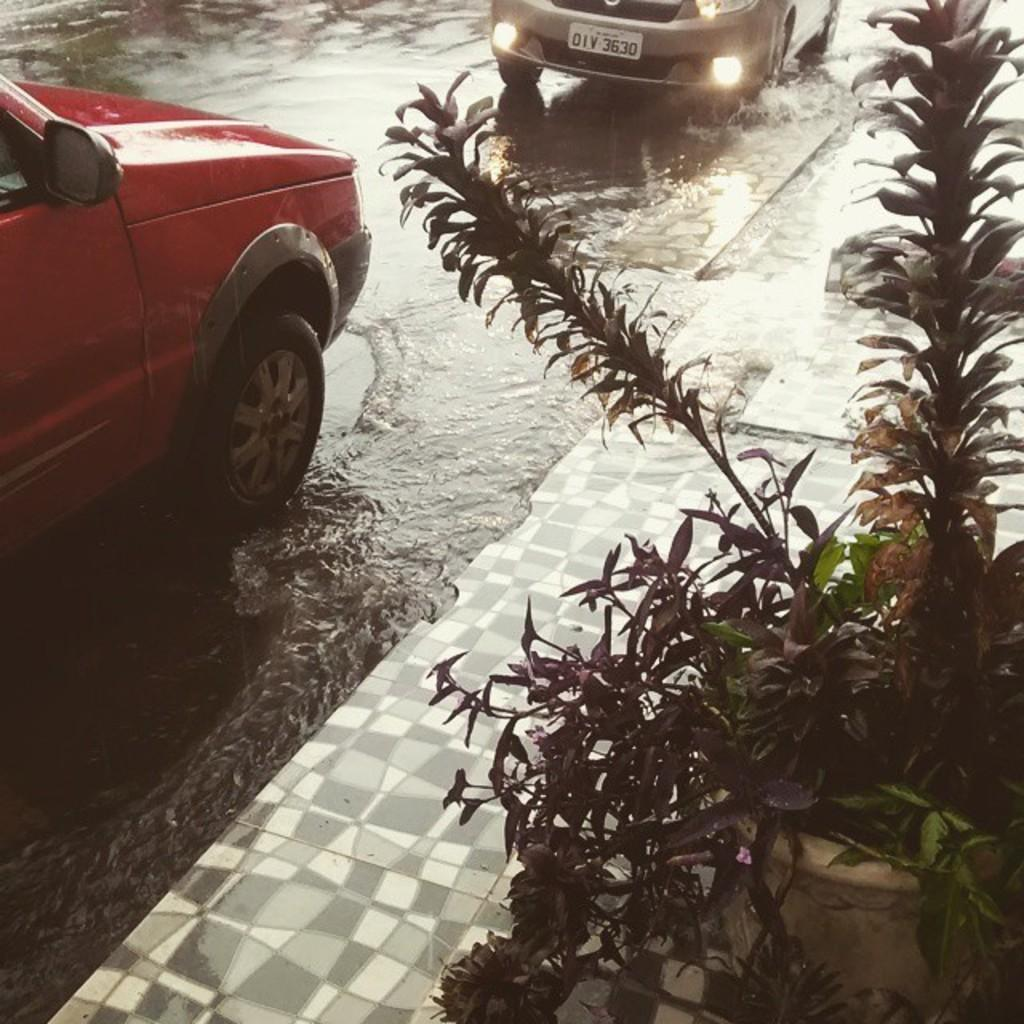What is visible in the image? There is water visible in the image. What else can be seen in the image? There are two cars on the road in the image. Is there any vegetation present in the image? Yes, there is a flower pot with a plant on the right side of the image. How many clovers can be seen growing near the plant in the image? There are no clovers visible in the image. Is there a cobweb present on the cars in the image? There is no mention of a cobweb in the image, and it is not visible in the provided facts. 